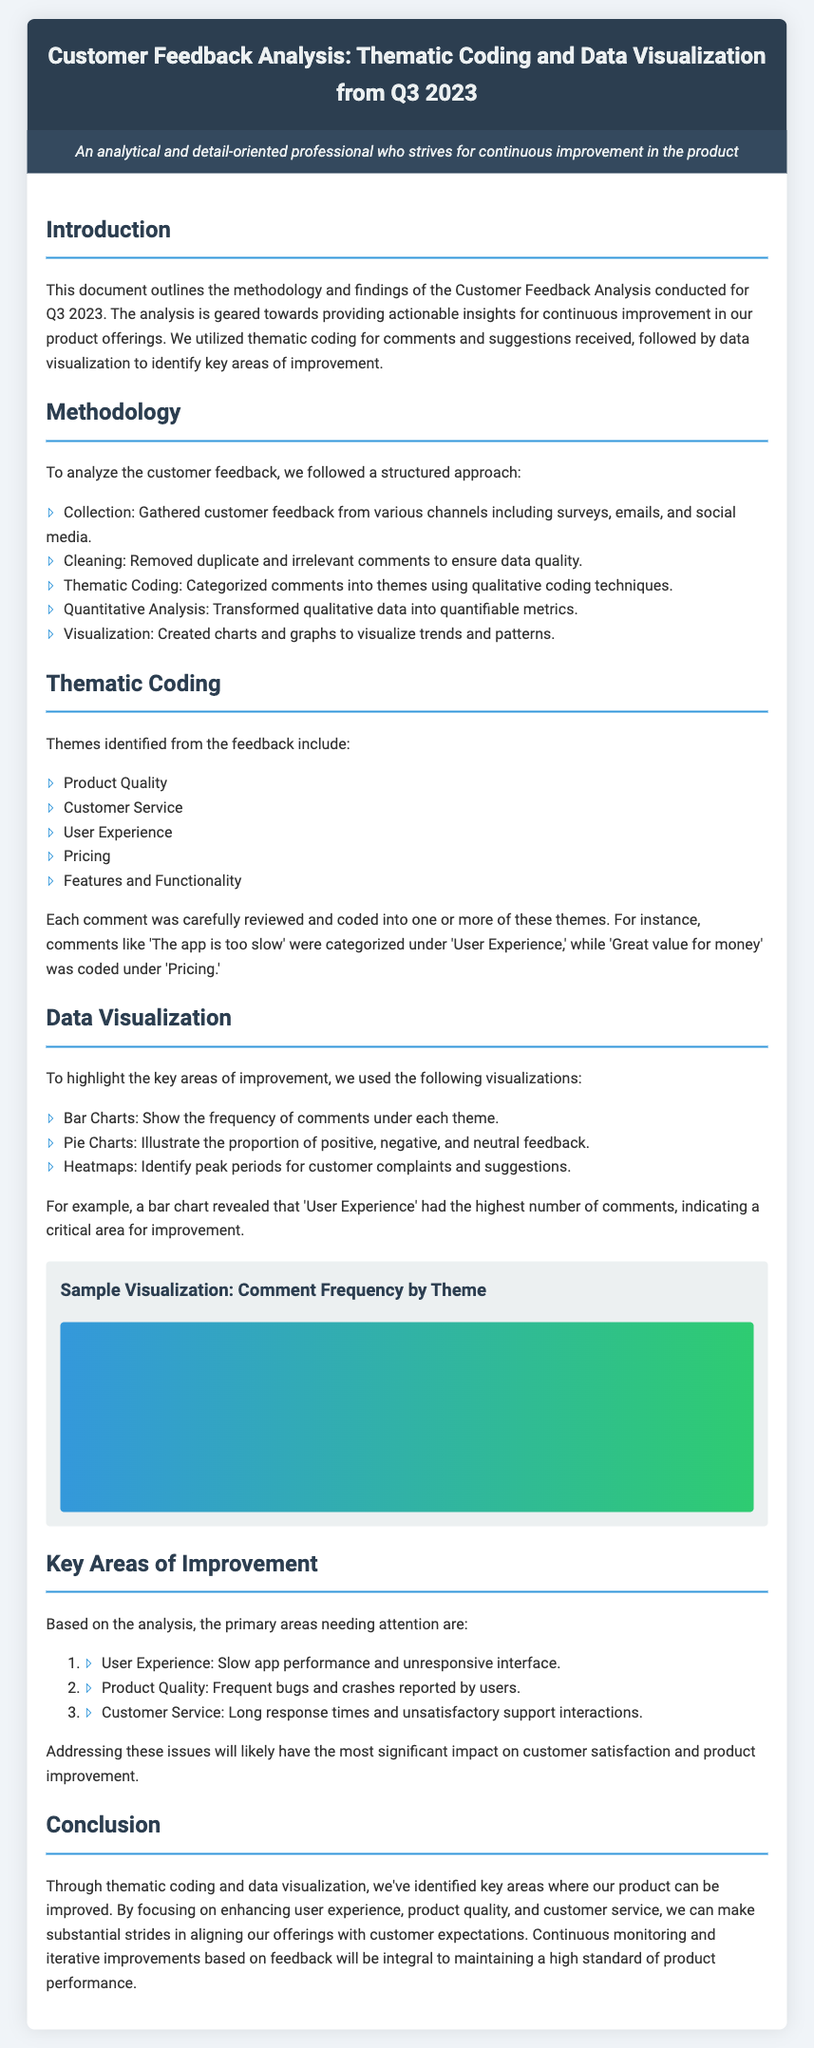What are the primary areas needing attention? The document lists three primary areas that need improvement based on the analysis.
Answer: User Experience, Product Quality, Customer Service How many themes were identified from the feedback? Thematic coding categorized the feedback into a specific number of themes.
Answer: Five What was the highest number of comments related to? The analysis revealed that one particular theme received the highest feedback, indicating critical improvement needs.
Answer: User Experience What is the document's main purpose? The main objective of the document is summarized in the introduction, where it describes the focus of the analysis.
Answer: Providing actionable insights for continuous improvement What type of charts were used for visualization? The document lists specific types of visual tools employed to represent the data collected from customer feedback.
Answer: Bar Charts, Pie Charts, Heatmaps What was the method used for cleaning data? The methodology section outlines a step taken to ensure the quality of the feedback data before analysis.
Answer: Removed duplicate and irrelevant comments What aspect of customer service needs improvement? The document highlights specific issues mentioned by customers regarding customer service.
Answer: Long response times and unsatisfactory support interactions What technique was used to categorize comments? The thematic coding section explains the method used to classify the comments gathered.
Answer: Qualitative coding techniques 